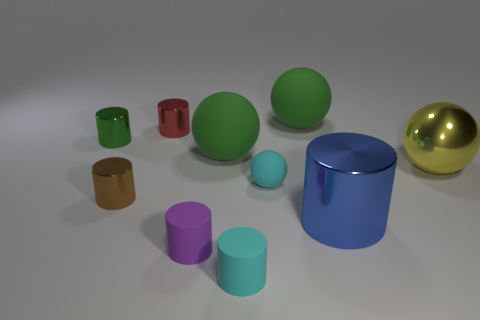Is the material of the tiny purple thing the same as the tiny cyan object behind the blue metal cylinder? While the materials of the tiny purple and cyan objects may look similar in the image, using visual cues only, it's impossible to confirm if their materials are identical without additional information such as texture, composition, or reflections under different lighting conditions. 